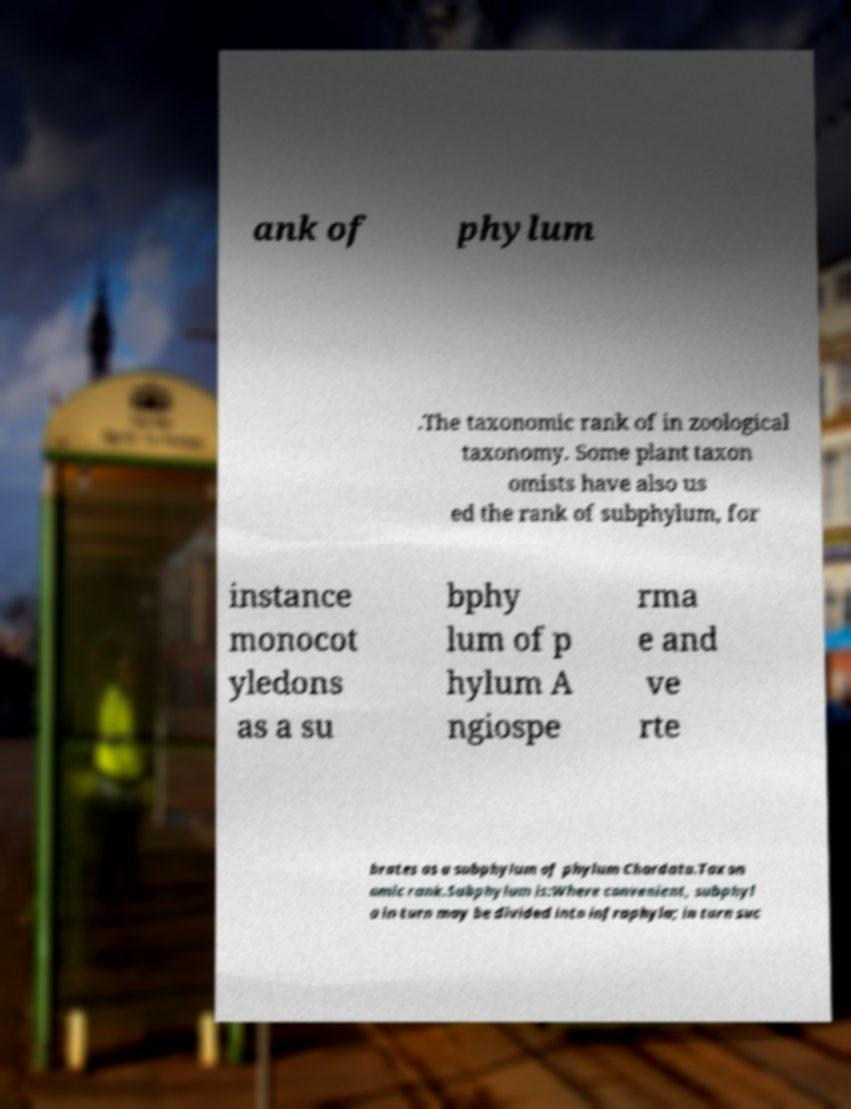Could you extract and type out the text from this image? ank of phylum .The taxonomic rank of in zoological taxonomy. Some plant taxon omists have also us ed the rank of subphylum, for instance monocot yledons as a su bphy lum of p hylum A ngiospe rma e and ve rte brates as a subphylum of phylum Chordata.Taxon omic rank.Subphylum is:Where convenient, subphyl a in turn may be divided into infraphyla; in turn suc 